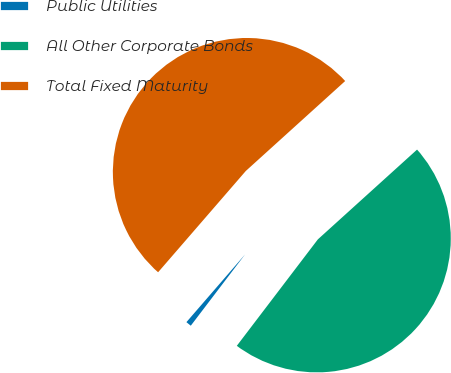Convert chart. <chart><loc_0><loc_0><loc_500><loc_500><pie_chart><fcel>Public Utilities<fcel>All Other Corporate Bonds<fcel>Total Fixed Maturity<nl><fcel>1.0%<fcel>47.06%<fcel>51.93%<nl></chart> 